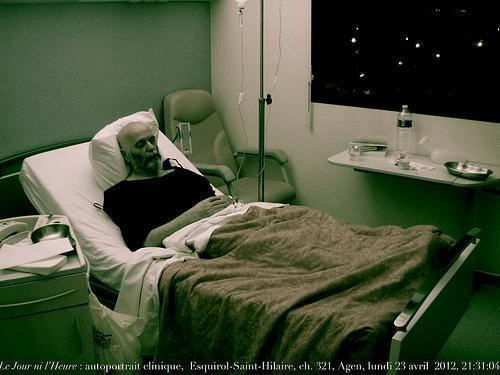How many beds are there?
Give a very brief answer. 1. 